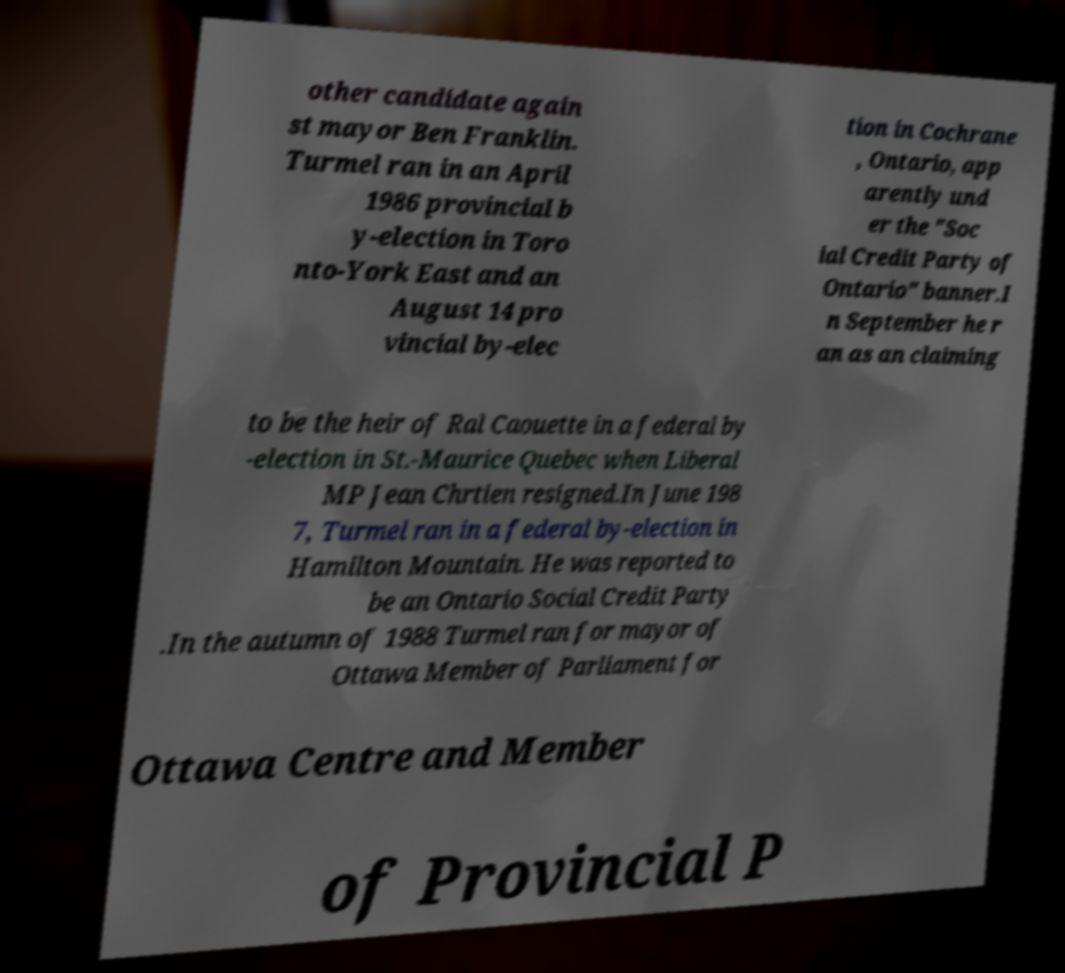What messages or text are displayed in this image? I need them in a readable, typed format. other candidate again st mayor Ben Franklin. Turmel ran in an April 1986 provincial b y-election in Toro nto-York East and an August 14 pro vincial by-elec tion in Cochrane , Ontario, app arently und er the "Soc ial Credit Party of Ontario" banner.I n September he r an as an claiming to be the heir of Ral Caouette in a federal by -election in St.-Maurice Quebec when Liberal MP Jean Chrtien resigned.In June 198 7, Turmel ran in a federal by-election in Hamilton Mountain. He was reported to be an Ontario Social Credit Party .In the autumn of 1988 Turmel ran for mayor of Ottawa Member of Parliament for Ottawa Centre and Member of Provincial P 